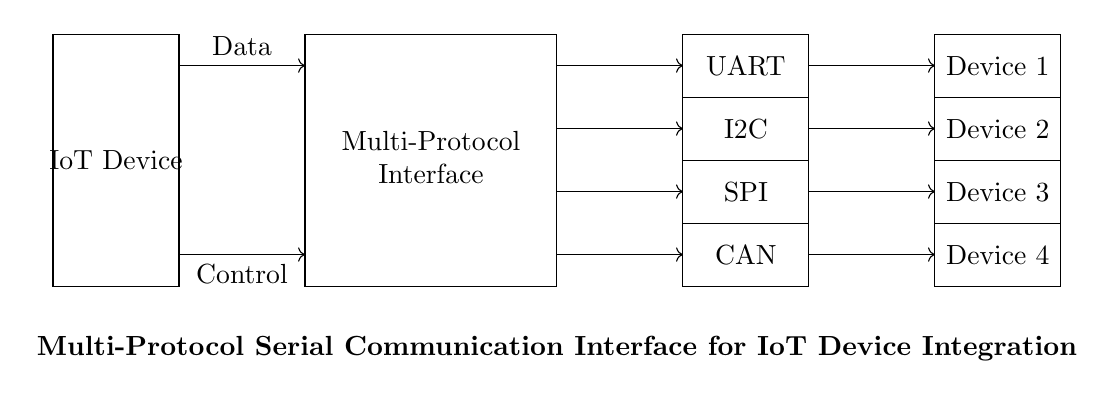What protocols are included in the multi-protocol interface? The protocols visible in the diagram are UART, I2C, SPI, and CAN, which are stacked vertically within the multi-protocol interface box.
Answer: UART, I2C, SPI, CAN How many external devices are connected? The diagram shows four external devices labeled as Device 1, Device 2, Device 3, and Device 4, indicating that there are four separate devices connected to the multi-protocol interface.
Answer: Four What type of connection is used between the IoT device and the multi-protocol interface? There are arrows indicating a data connection and a control connection from the IoT device to the multi-protocol interface, suggesting directional flow of information.
Answer: Data and Control Which component does the control line connect to? The control line connects from the IoT device to the multi-protocol interface, as shown by the arrow pointing from the IoT device to the multi-protocol section.
Answer: Multi-Protocol Interface Which external device is connected using the SPI protocol? The third external device, corresponding to the position of the SPI protocol in the multi-protocol interface, connects with an arrow indicating the flow of communication between them.
Answer: Device 3 What is the direction of data flow from the multi-protocol interface to the external devices? The arrows indicate that data flows from the multi-protocol interface to each of the four external devices, suggesting that the interface sends out the data to them.
Answer: Outward 